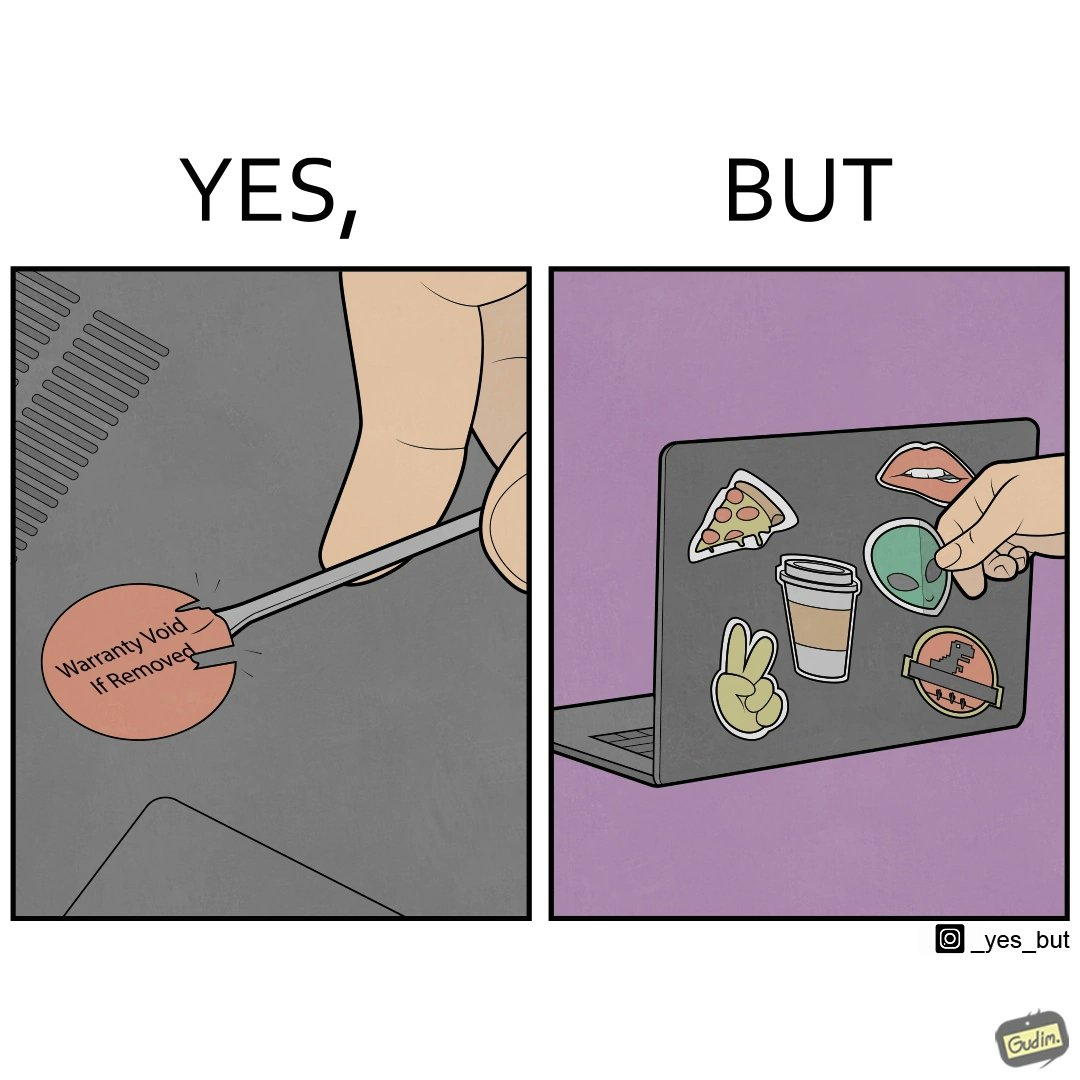Describe what you see in the left and right parts of this image. In the left part of the image: It is a warranty sticker being removed with a screwdriver In the right part of the image: It is an user sticking multiple stickers on their laptop 